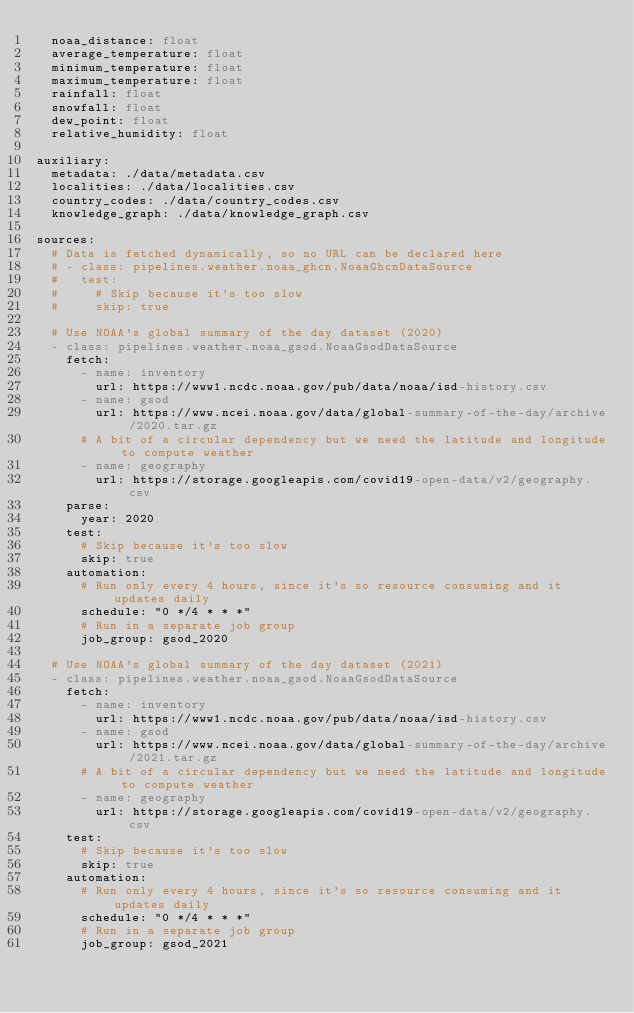<code> <loc_0><loc_0><loc_500><loc_500><_YAML_>  noaa_distance: float
  average_temperature: float
  minimum_temperature: float
  maximum_temperature: float
  rainfall: float
  snowfall: float
  dew_point: float
  relative_humidity: float

auxiliary:
  metadata: ./data/metadata.csv
  localities: ./data/localities.csv
  country_codes: ./data/country_codes.csv
  knowledge_graph: ./data/knowledge_graph.csv

sources:
  # Data is fetched dynamically, so no URL can be declared here
  # - class: pipelines.weather.noaa_ghcn.NoaaGhcnDataSource
  #   test:
  #     # Skip because it's too slow
  #     skip: true

  # Use NOAA's global summary of the day dataset (2020)
  - class: pipelines.weather.noaa_gsod.NoaaGsodDataSource
    fetch:
      - name: inventory
        url: https://www1.ncdc.noaa.gov/pub/data/noaa/isd-history.csv
      - name: gsod
        url: https://www.ncei.noaa.gov/data/global-summary-of-the-day/archive/2020.tar.gz
      # A bit of a circular dependency but we need the latitude and longitude to compute weather
      - name: geography
        url: https://storage.googleapis.com/covid19-open-data/v2/geography.csv
    parse:
      year: 2020
    test:
      # Skip because it's too slow
      skip: true
    automation:
      # Run only every 4 hours, since it's so resource consuming and it updates daily
      schedule: "0 */4 * * *"
      # Run in a separate job group
      job_group: gsod_2020

  # Use NOAA's global summary of the day dataset (2021)
  - class: pipelines.weather.noaa_gsod.NoaaGsodDataSource
    fetch:
      - name: inventory
        url: https://www1.ncdc.noaa.gov/pub/data/noaa/isd-history.csv
      - name: gsod
        url: https://www.ncei.noaa.gov/data/global-summary-of-the-day/archive/2021.tar.gz
      # A bit of a circular dependency but we need the latitude and longitude to compute weather
      - name: geography
        url: https://storage.googleapis.com/covid19-open-data/v2/geography.csv
    test:
      # Skip because it's too slow
      skip: true
    automation:
      # Run only every 4 hours, since it's so resource consuming and it updates daily
      schedule: "0 */4 * * *"
      # Run in a separate job group
      job_group: gsod_2021
</code> 